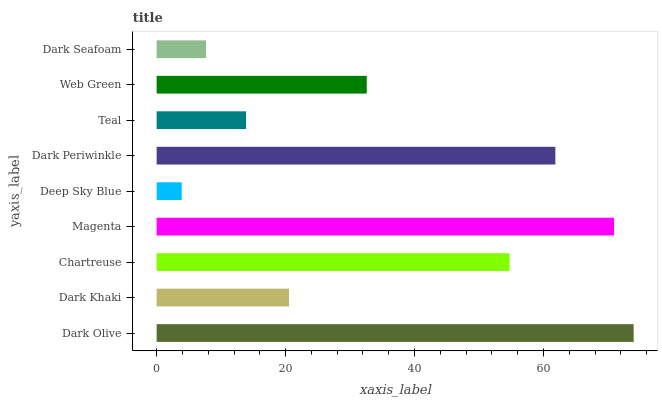Is Deep Sky Blue the minimum?
Answer yes or no. Yes. Is Dark Olive the maximum?
Answer yes or no. Yes. Is Dark Khaki the minimum?
Answer yes or no. No. Is Dark Khaki the maximum?
Answer yes or no. No. Is Dark Olive greater than Dark Khaki?
Answer yes or no. Yes. Is Dark Khaki less than Dark Olive?
Answer yes or no. Yes. Is Dark Khaki greater than Dark Olive?
Answer yes or no. No. Is Dark Olive less than Dark Khaki?
Answer yes or no. No. Is Web Green the high median?
Answer yes or no. Yes. Is Web Green the low median?
Answer yes or no. Yes. Is Dark Periwinkle the high median?
Answer yes or no. No. Is Magenta the low median?
Answer yes or no. No. 